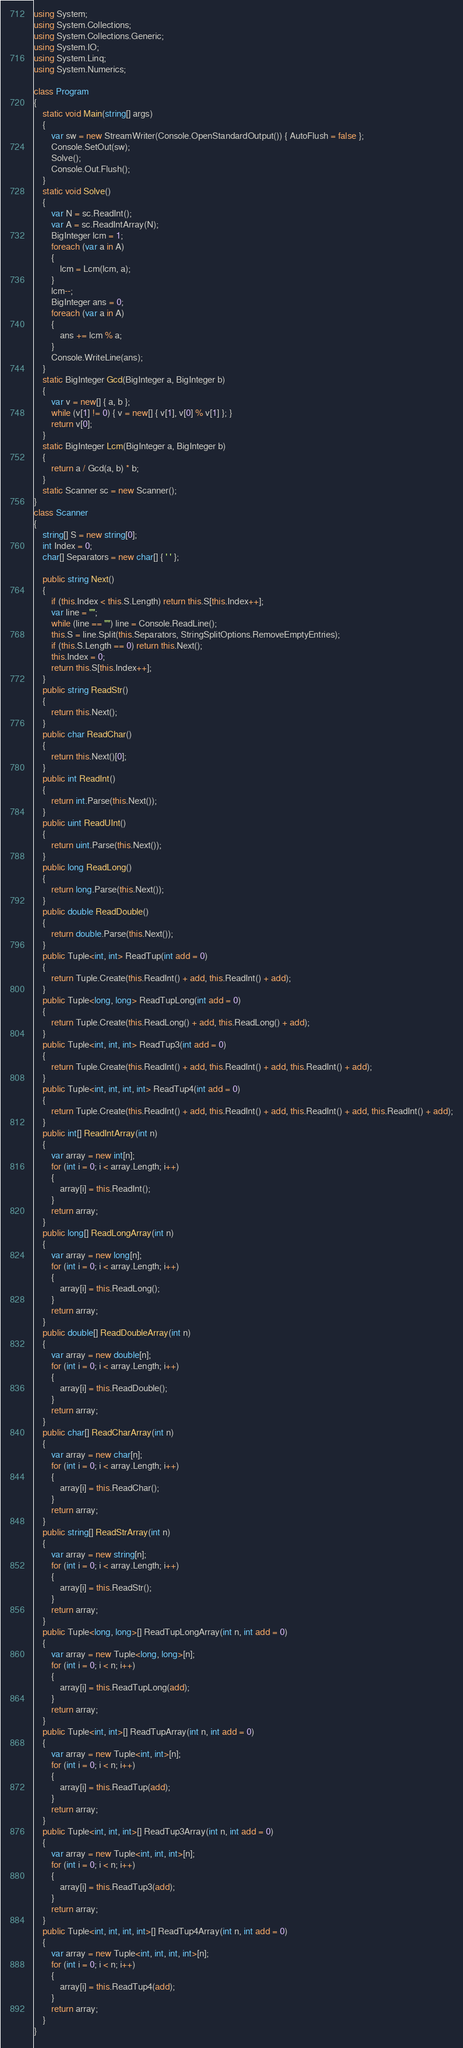<code> <loc_0><loc_0><loc_500><loc_500><_C#_>using System;
using System.Collections;
using System.Collections.Generic;
using System.IO;
using System.Linq;
using System.Numerics;

class Program
{
    static void Main(string[] args)
    {
        var sw = new StreamWriter(Console.OpenStandardOutput()) { AutoFlush = false };
        Console.SetOut(sw);
        Solve();
        Console.Out.Flush();
    }
    static void Solve()
    {
        var N = sc.ReadInt();
        var A = sc.ReadIntArray(N);
        BigInteger lcm = 1;
        foreach (var a in A)
        {
            lcm = Lcm(lcm, a);
        }
        lcm--;
        BigInteger ans = 0;
        foreach (var a in A)
        {
            ans += lcm % a;
        }
        Console.WriteLine(ans);
    }
    static BigInteger Gcd(BigInteger a, BigInteger b)
    {
        var v = new[] { a, b };
        while (v[1] != 0) { v = new[] { v[1], v[0] % v[1] }; }
        return v[0];
    }
    static BigInteger Lcm(BigInteger a, BigInteger b)
    {
        return a / Gcd(a, b) * b;
    }
    static Scanner sc = new Scanner();
}
class Scanner
{
    string[] S = new string[0];
    int Index = 0;
    char[] Separators = new char[] { ' ' };

    public string Next()
    {
        if (this.Index < this.S.Length) return this.S[this.Index++];
        var line = "";
        while (line == "") line = Console.ReadLine();
        this.S = line.Split(this.Separators, StringSplitOptions.RemoveEmptyEntries);
        if (this.S.Length == 0) return this.Next();
        this.Index = 0;
        return this.S[this.Index++];
    }
    public string ReadStr()
    {
        return this.Next();
    }
    public char ReadChar()
    {
        return this.Next()[0];
    }
    public int ReadInt()
    {
        return int.Parse(this.Next());
    }
    public uint ReadUInt()
    {
        return uint.Parse(this.Next());
    }
    public long ReadLong()
    {
        return long.Parse(this.Next());
    }
    public double ReadDouble()
    {
        return double.Parse(this.Next());
    }
    public Tuple<int, int> ReadTup(int add = 0)
    {
        return Tuple.Create(this.ReadInt() + add, this.ReadInt() + add);
    }
    public Tuple<long, long> ReadTupLong(int add = 0)
    {
        return Tuple.Create(this.ReadLong() + add, this.ReadLong() + add);
    }
    public Tuple<int, int, int> ReadTup3(int add = 0)
    {
        return Tuple.Create(this.ReadInt() + add, this.ReadInt() + add, this.ReadInt() + add);
    }
    public Tuple<int, int, int, int> ReadTup4(int add = 0)
    {
        return Tuple.Create(this.ReadInt() + add, this.ReadInt() + add, this.ReadInt() + add, this.ReadInt() + add);
    }
    public int[] ReadIntArray(int n)
    {
        var array = new int[n];
        for (int i = 0; i < array.Length; i++)
        {
            array[i] = this.ReadInt();
        }
        return array;
    }
    public long[] ReadLongArray(int n)
    {
        var array = new long[n];
        for (int i = 0; i < array.Length; i++)
        {
            array[i] = this.ReadLong();
        }
        return array;
    }
    public double[] ReadDoubleArray(int n)
    {
        var array = new double[n];
        for (int i = 0; i < array.Length; i++)
        {
            array[i] = this.ReadDouble();
        }
        return array;
    }
    public char[] ReadCharArray(int n)
    {
        var array = new char[n];
        for (int i = 0; i < array.Length; i++)
        {
            array[i] = this.ReadChar();
        }
        return array;
    }
    public string[] ReadStrArray(int n)
    {
        var array = new string[n];
        for (int i = 0; i < array.Length; i++)
        {
            array[i] = this.ReadStr();
        }
        return array;
    }
    public Tuple<long, long>[] ReadTupLongArray(int n, int add = 0)
    {
        var array = new Tuple<long, long>[n];
        for (int i = 0; i < n; i++)
        {
            array[i] = this.ReadTupLong(add);
        }
        return array;
    }
    public Tuple<int, int>[] ReadTupArray(int n, int add = 0)
    {
        var array = new Tuple<int, int>[n];
        for (int i = 0; i < n; i++)
        {
            array[i] = this.ReadTup(add);
        }
        return array;
    }
    public Tuple<int, int, int>[] ReadTup3Array(int n, int add = 0)
    {
        var array = new Tuple<int, int, int>[n];
        for (int i = 0; i < n; i++)
        {
            array[i] = this.ReadTup3(add);
        }
        return array;
    }
    public Tuple<int, int, int, int>[] ReadTup4Array(int n, int add = 0)
    {
        var array = new Tuple<int, int, int, int>[n];
        for (int i = 0; i < n; i++)
        {
            array[i] = this.ReadTup4(add);
        }
        return array;
    }
}
</code> 